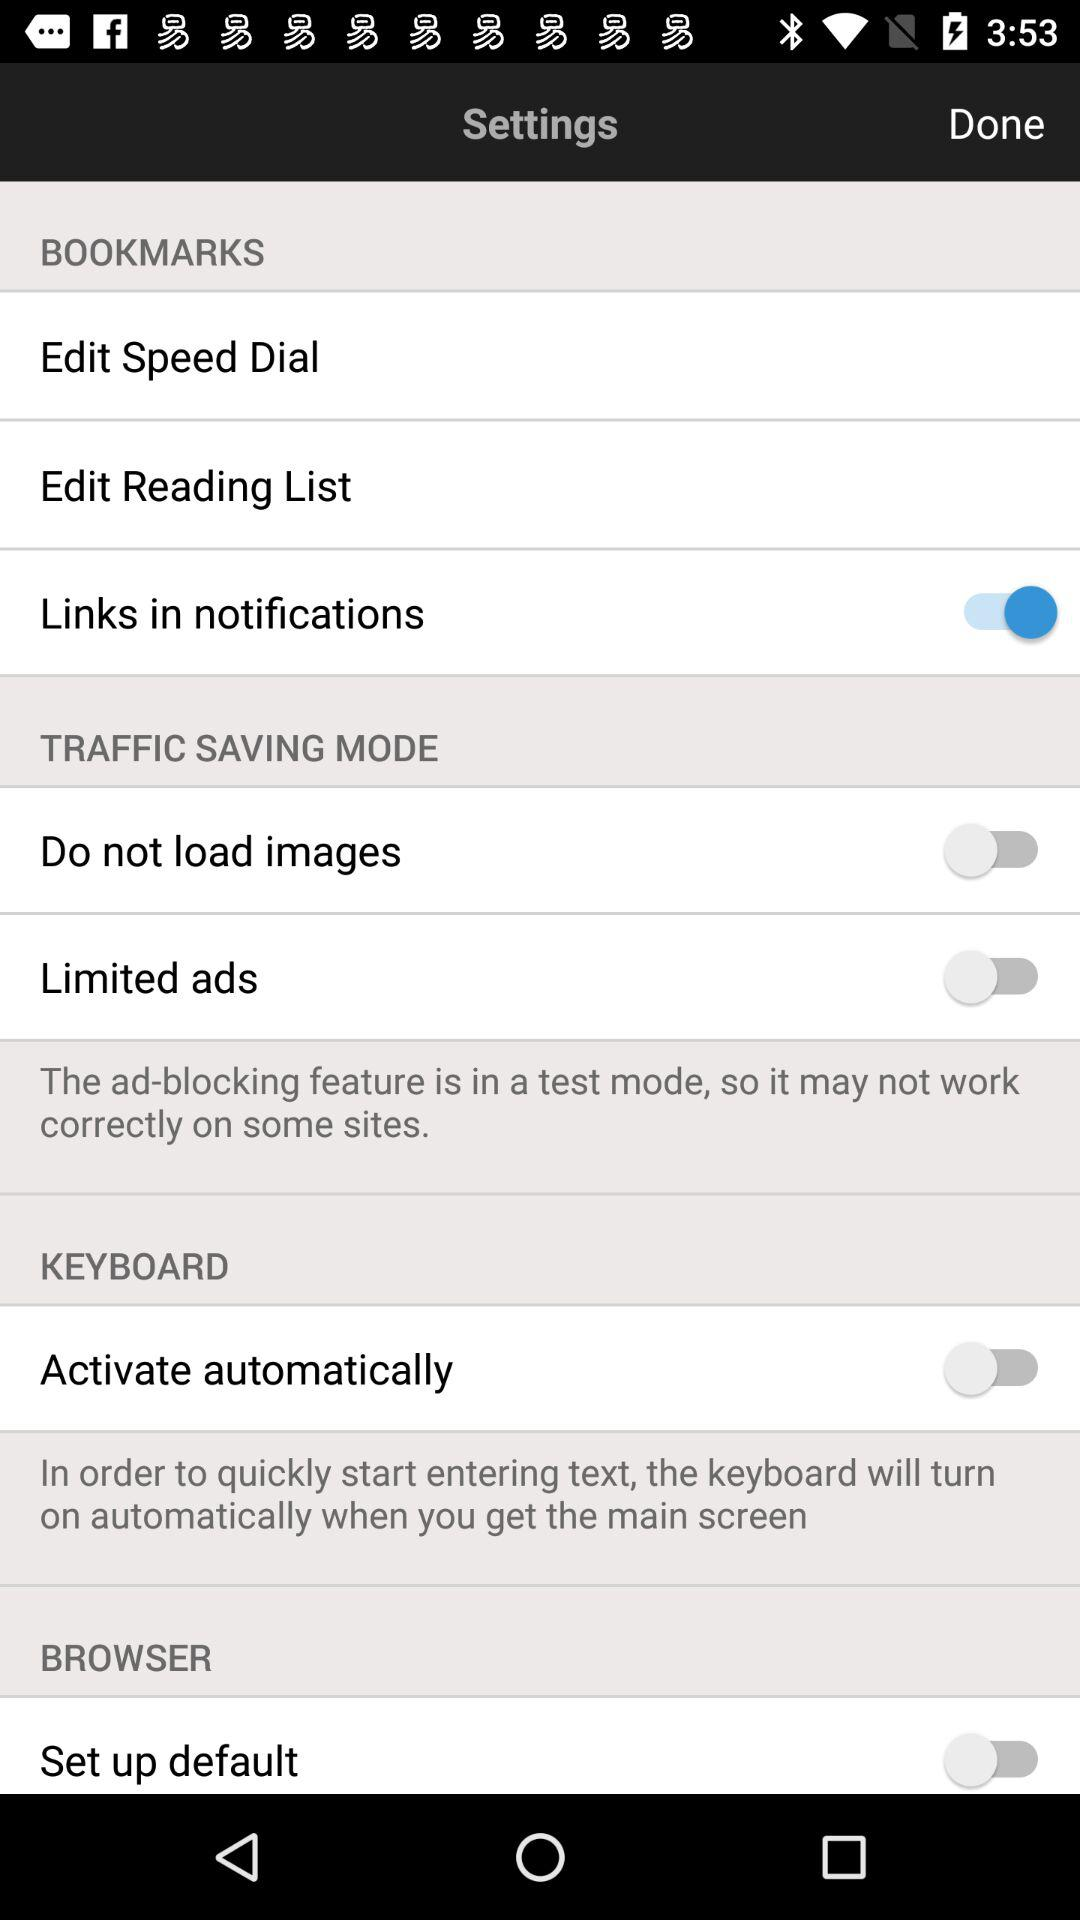What is the setting for "Activate automatically"? The setting for "Activate automatically" is "off". 